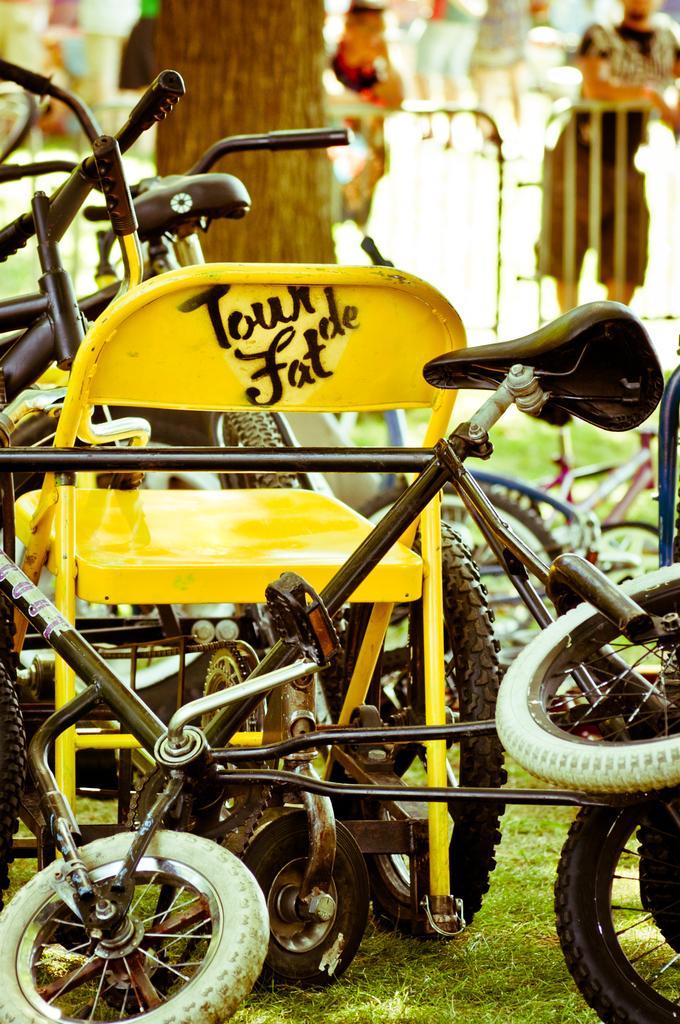In one or two sentences, can you explain what this image depicts? In the picture there are many cycles kept in front of a tree on the ground and the background of the tree is blur. 